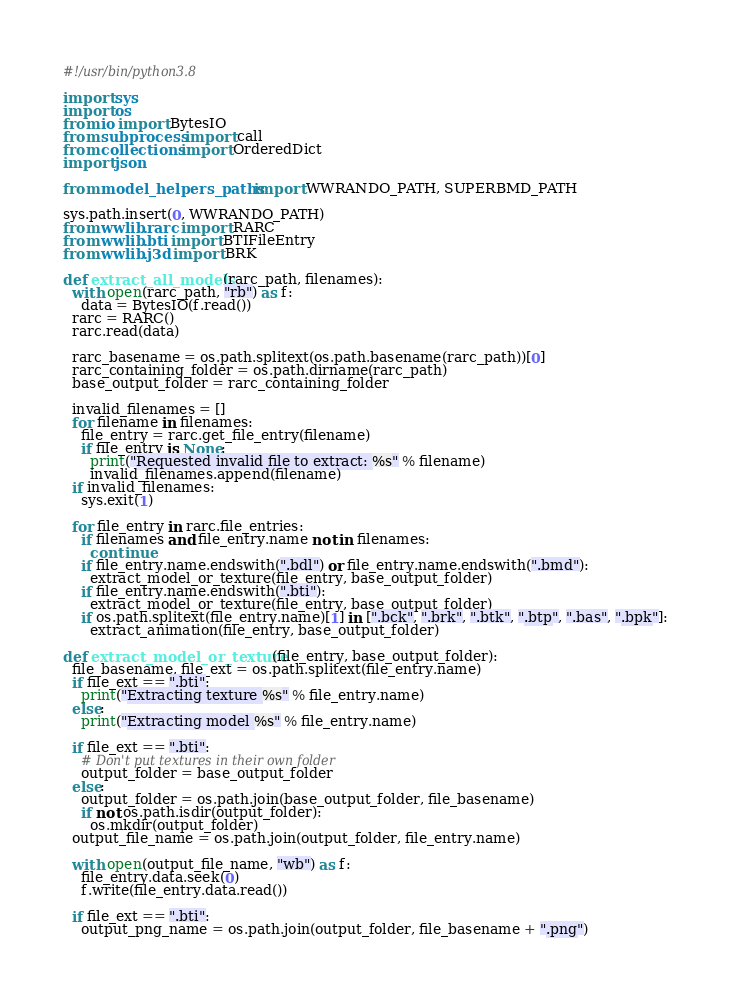<code> <loc_0><loc_0><loc_500><loc_500><_Python_>#!/usr/bin/python3.8

import sys
import os
from io import BytesIO
from subprocess import call
from collections import OrderedDict
import json

from model_helpers_paths import WWRANDO_PATH, SUPERBMD_PATH

sys.path.insert(0, WWRANDO_PATH)
from wwlib.rarc import RARC
from wwlib.bti import BTIFileEntry
from wwlib.j3d import BRK

def extract_all_models(rarc_path, filenames):
  with open(rarc_path, "rb") as f:
    data = BytesIO(f.read())
  rarc = RARC()
  rarc.read(data)
  
  rarc_basename = os.path.splitext(os.path.basename(rarc_path))[0]
  rarc_containing_folder = os.path.dirname(rarc_path)
  base_output_folder = rarc_containing_folder
  
  invalid_filenames = []
  for filename in filenames:
    file_entry = rarc.get_file_entry(filename)
    if file_entry is None:
      print("Requested invalid file to extract: %s" % filename)
      invalid_filenames.append(filename)
  if invalid_filenames:
    sys.exit(1)
  
  for file_entry in rarc.file_entries:
    if filenames and file_entry.name not in filenames:
      continue
    if file_entry.name.endswith(".bdl") or file_entry.name.endswith(".bmd"):
      extract_model_or_texture(file_entry, base_output_folder)
    if file_entry.name.endswith(".bti"):
      extract_model_or_texture(file_entry, base_output_folder)
    if os.path.splitext(file_entry.name)[1] in [".bck", ".brk", ".btk", ".btp", ".bas", ".bpk"]:
      extract_animation(file_entry, base_output_folder)

def extract_model_or_texture(file_entry, base_output_folder):
  file_basename, file_ext = os.path.splitext(file_entry.name)
  if file_ext == ".bti":
    print("Extracting texture %s" % file_entry.name)
  else:
    print("Extracting model %s" % file_entry.name)
  
  if file_ext == ".bti":
    # Don't put textures in their own folder
    output_folder = base_output_folder
  else:
    output_folder = os.path.join(base_output_folder, file_basename)
    if not os.path.isdir(output_folder):
      os.mkdir(output_folder)
  output_file_name = os.path.join(output_folder, file_entry.name)
  
  with open(output_file_name, "wb") as f:
    file_entry.data.seek(0)
    f.write(file_entry.data.read())
  
  if file_ext == ".bti":
    output_png_name = os.path.join(output_folder, file_basename + ".png")</code> 